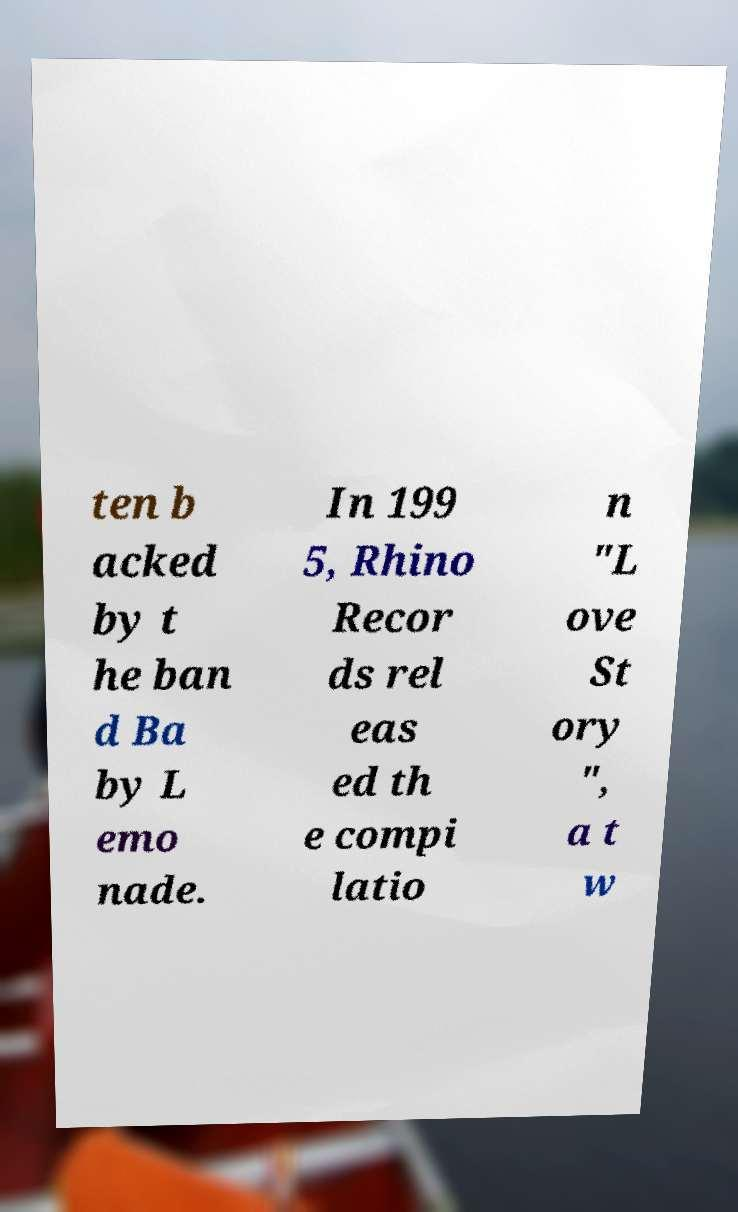Please identify and transcribe the text found in this image. ten b acked by t he ban d Ba by L emo nade. In 199 5, Rhino Recor ds rel eas ed th e compi latio n "L ove St ory ", a t w 